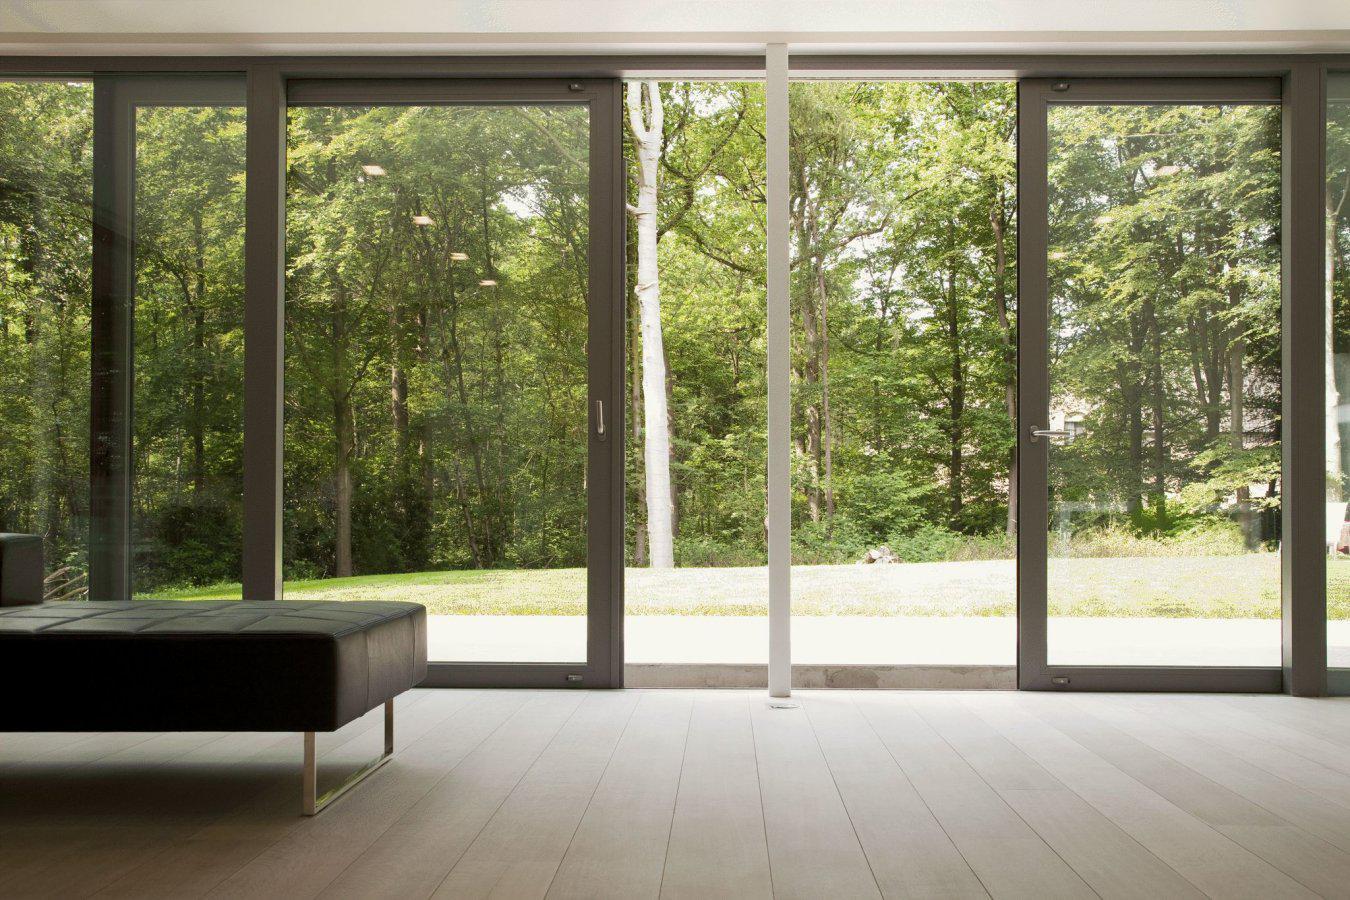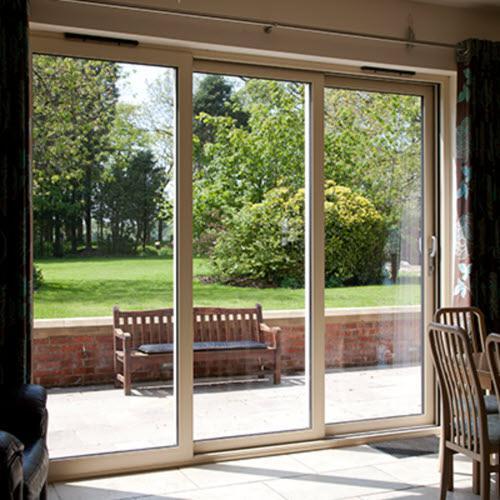The first image is the image on the left, the second image is the image on the right. Given the left and right images, does the statement "The right image is an exterior view of a white dark-framed sliding door unit, opened to show a furnished home interior." hold true? Answer yes or no. No. The first image is the image on the left, the second image is the image on the right. Evaluate the accuracy of this statement regarding the images: "there is a home with sliding glass doors open and looking into a living area from the outside". Is it true? Answer yes or no. No. 